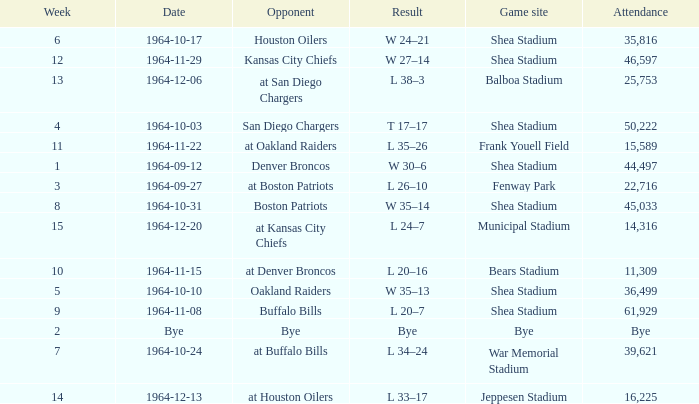What's the Result for week 15? L 24–7. 